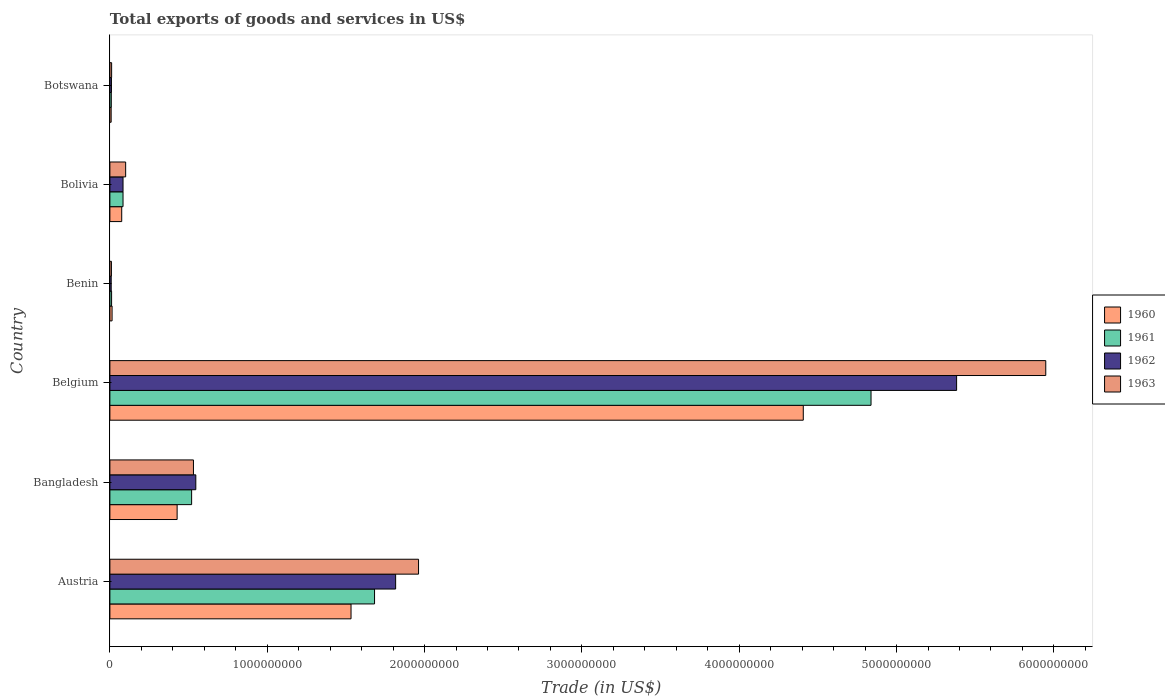Are the number of bars per tick equal to the number of legend labels?
Offer a very short reply. Yes. Are the number of bars on each tick of the Y-axis equal?
Your response must be concise. Yes. What is the label of the 1st group of bars from the top?
Make the answer very short. Botswana. In how many cases, is the number of bars for a given country not equal to the number of legend labels?
Make the answer very short. 0. What is the total exports of goods and services in 1961 in Austria?
Make the answer very short. 1.68e+09. Across all countries, what is the maximum total exports of goods and services in 1960?
Provide a short and direct response. 4.41e+09. Across all countries, what is the minimum total exports of goods and services in 1961?
Your answer should be very brief. 8.95e+06. In which country was the total exports of goods and services in 1960 maximum?
Make the answer very short. Belgium. In which country was the total exports of goods and services in 1961 minimum?
Your answer should be very brief. Botswana. What is the total total exports of goods and services in 1960 in the graph?
Ensure brevity in your answer.  6.46e+09. What is the difference between the total exports of goods and services in 1961 in Bangladesh and that in Belgium?
Offer a terse response. -4.32e+09. What is the difference between the total exports of goods and services in 1962 in Botswana and the total exports of goods and services in 1961 in Belgium?
Give a very brief answer. -4.83e+09. What is the average total exports of goods and services in 1960 per country?
Your response must be concise. 1.08e+09. What is the difference between the total exports of goods and services in 1961 and total exports of goods and services in 1960 in Bolivia?
Your answer should be very brief. 8.35e+06. What is the ratio of the total exports of goods and services in 1962 in Austria to that in Belgium?
Your answer should be very brief. 0.34. Is the difference between the total exports of goods and services in 1961 in Austria and Belgium greater than the difference between the total exports of goods and services in 1960 in Austria and Belgium?
Provide a short and direct response. No. What is the difference between the highest and the second highest total exports of goods and services in 1960?
Your answer should be very brief. 2.87e+09. What is the difference between the highest and the lowest total exports of goods and services in 1963?
Ensure brevity in your answer.  5.94e+09. Is the sum of the total exports of goods and services in 1961 in Bangladesh and Bolivia greater than the maximum total exports of goods and services in 1960 across all countries?
Your answer should be very brief. No. Is it the case that in every country, the sum of the total exports of goods and services in 1963 and total exports of goods and services in 1960 is greater than the total exports of goods and services in 1962?
Your answer should be very brief. Yes. Are all the bars in the graph horizontal?
Provide a succinct answer. Yes. How many countries are there in the graph?
Your answer should be very brief. 6. What is the difference between two consecutive major ticks on the X-axis?
Your response must be concise. 1.00e+09. Are the values on the major ticks of X-axis written in scientific E-notation?
Provide a succinct answer. No. Where does the legend appear in the graph?
Provide a short and direct response. Center right. How are the legend labels stacked?
Ensure brevity in your answer.  Vertical. What is the title of the graph?
Your answer should be very brief. Total exports of goods and services in US$. What is the label or title of the X-axis?
Offer a terse response. Trade (in US$). What is the Trade (in US$) of 1960 in Austria?
Keep it short and to the point. 1.53e+09. What is the Trade (in US$) of 1961 in Austria?
Provide a succinct answer. 1.68e+09. What is the Trade (in US$) in 1962 in Austria?
Offer a very short reply. 1.82e+09. What is the Trade (in US$) in 1963 in Austria?
Your answer should be compact. 1.96e+09. What is the Trade (in US$) in 1960 in Bangladesh?
Give a very brief answer. 4.27e+08. What is the Trade (in US$) in 1961 in Bangladesh?
Your response must be concise. 5.19e+08. What is the Trade (in US$) in 1962 in Bangladesh?
Provide a succinct answer. 5.46e+08. What is the Trade (in US$) of 1963 in Bangladesh?
Keep it short and to the point. 5.31e+08. What is the Trade (in US$) in 1960 in Belgium?
Offer a very short reply. 4.41e+09. What is the Trade (in US$) in 1961 in Belgium?
Give a very brief answer. 4.84e+09. What is the Trade (in US$) of 1962 in Belgium?
Your answer should be compact. 5.38e+09. What is the Trade (in US$) of 1963 in Belgium?
Your response must be concise. 5.95e+09. What is the Trade (in US$) in 1960 in Benin?
Ensure brevity in your answer.  1.39e+07. What is the Trade (in US$) in 1961 in Benin?
Give a very brief answer. 1.08e+07. What is the Trade (in US$) of 1962 in Benin?
Keep it short and to the point. 8.32e+06. What is the Trade (in US$) of 1963 in Benin?
Offer a very short reply. 9.70e+06. What is the Trade (in US$) of 1960 in Bolivia?
Make the answer very short. 7.51e+07. What is the Trade (in US$) of 1961 in Bolivia?
Keep it short and to the point. 8.35e+07. What is the Trade (in US$) in 1962 in Bolivia?
Provide a succinct answer. 8.35e+07. What is the Trade (in US$) in 1963 in Bolivia?
Provide a succinct answer. 1.00e+08. What is the Trade (in US$) in 1960 in Botswana?
Your answer should be compact. 7.99e+06. What is the Trade (in US$) in 1961 in Botswana?
Provide a succinct answer. 8.95e+06. What is the Trade (in US$) in 1962 in Botswana?
Offer a very short reply. 9.95e+06. What is the Trade (in US$) in 1963 in Botswana?
Your response must be concise. 1.10e+07. Across all countries, what is the maximum Trade (in US$) in 1960?
Provide a succinct answer. 4.41e+09. Across all countries, what is the maximum Trade (in US$) of 1961?
Offer a very short reply. 4.84e+09. Across all countries, what is the maximum Trade (in US$) in 1962?
Offer a very short reply. 5.38e+09. Across all countries, what is the maximum Trade (in US$) in 1963?
Your answer should be compact. 5.95e+09. Across all countries, what is the minimum Trade (in US$) in 1960?
Ensure brevity in your answer.  7.99e+06. Across all countries, what is the minimum Trade (in US$) of 1961?
Keep it short and to the point. 8.95e+06. Across all countries, what is the minimum Trade (in US$) in 1962?
Your answer should be compact. 8.32e+06. Across all countries, what is the minimum Trade (in US$) of 1963?
Offer a terse response. 9.70e+06. What is the total Trade (in US$) in 1960 in the graph?
Your answer should be compact. 6.46e+09. What is the total Trade (in US$) of 1961 in the graph?
Keep it short and to the point. 7.14e+09. What is the total Trade (in US$) in 1962 in the graph?
Give a very brief answer. 7.85e+09. What is the total Trade (in US$) in 1963 in the graph?
Your response must be concise. 8.56e+09. What is the difference between the Trade (in US$) of 1960 in Austria and that in Bangladesh?
Ensure brevity in your answer.  1.11e+09. What is the difference between the Trade (in US$) of 1961 in Austria and that in Bangladesh?
Offer a terse response. 1.16e+09. What is the difference between the Trade (in US$) of 1962 in Austria and that in Bangladesh?
Your answer should be very brief. 1.27e+09. What is the difference between the Trade (in US$) in 1963 in Austria and that in Bangladesh?
Offer a terse response. 1.43e+09. What is the difference between the Trade (in US$) in 1960 in Austria and that in Belgium?
Give a very brief answer. -2.87e+09. What is the difference between the Trade (in US$) in 1961 in Austria and that in Belgium?
Give a very brief answer. -3.16e+09. What is the difference between the Trade (in US$) in 1962 in Austria and that in Belgium?
Your response must be concise. -3.57e+09. What is the difference between the Trade (in US$) of 1963 in Austria and that in Belgium?
Your response must be concise. -3.99e+09. What is the difference between the Trade (in US$) of 1960 in Austria and that in Benin?
Keep it short and to the point. 1.52e+09. What is the difference between the Trade (in US$) of 1961 in Austria and that in Benin?
Ensure brevity in your answer.  1.67e+09. What is the difference between the Trade (in US$) of 1962 in Austria and that in Benin?
Provide a short and direct response. 1.81e+09. What is the difference between the Trade (in US$) in 1963 in Austria and that in Benin?
Provide a short and direct response. 1.95e+09. What is the difference between the Trade (in US$) of 1960 in Austria and that in Bolivia?
Your response must be concise. 1.46e+09. What is the difference between the Trade (in US$) in 1961 in Austria and that in Bolivia?
Offer a terse response. 1.60e+09. What is the difference between the Trade (in US$) of 1962 in Austria and that in Bolivia?
Your answer should be compact. 1.73e+09. What is the difference between the Trade (in US$) of 1963 in Austria and that in Bolivia?
Keep it short and to the point. 1.86e+09. What is the difference between the Trade (in US$) of 1960 in Austria and that in Botswana?
Offer a terse response. 1.52e+09. What is the difference between the Trade (in US$) in 1961 in Austria and that in Botswana?
Your answer should be compact. 1.67e+09. What is the difference between the Trade (in US$) of 1962 in Austria and that in Botswana?
Your answer should be compact. 1.81e+09. What is the difference between the Trade (in US$) of 1963 in Austria and that in Botswana?
Provide a succinct answer. 1.95e+09. What is the difference between the Trade (in US$) of 1960 in Bangladesh and that in Belgium?
Offer a terse response. -3.98e+09. What is the difference between the Trade (in US$) of 1961 in Bangladesh and that in Belgium?
Your answer should be compact. -4.32e+09. What is the difference between the Trade (in US$) of 1962 in Bangladesh and that in Belgium?
Offer a terse response. -4.84e+09. What is the difference between the Trade (in US$) of 1963 in Bangladesh and that in Belgium?
Provide a succinct answer. -5.42e+09. What is the difference between the Trade (in US$) in 1960 in Bangladesh and that in Benin?
Ensure brevity in your answer.  4.13e+08. What is the difference between the Trade (in US$) of 1961 in Bangladesh and that in Benin?
Keep it short and to the point. 5.09e+08. What is the difference between the Trade (in US$) in 1962 in Bangladesh and that in Benin?
Your response must be concise. 5.38e+08. What is the difference between the Trade (in US$) in 1963 in Bangladesh and that in Benin?
Give a very brief answer. 5.21e+08. What is the difference between the Trade (in US$) of 1960 in Bangladesh and that in Bolivia?
Ensure brevity in your answer.  3.52e+08. What is the difference between the Trade (in US$) of 1961 in Bangladesh and that in Bolivia?
Ensure brevity in your answer.  4.36e+08. What is the difference between the Trade (in US$) in 1962 in Bangladesh and that in Bolivia?
Offer a terse response. 4.63e+08. What is the difference between the Trade (in US$) of 1963 in Bangladesh and that in Bolivia?
Offer a terse response. 4.31e+08. What is the difference between the Trade (in US$) of 1960 in Bangladesh and that in Botswana?
Offer a terse response. 4.19e+08. What is the difference between the Trade (in US$) of 1961 in Bangladesh and that in Botswana?
Ensure brevity in your answer.  5.10e+08. What is the difference between the Trade (in US$) of 1962 in Bangladesh and that in Botswana?
Provide a succinct answer. 5.36e+08. What is the difference between the Trade (in US$) of 1963 in Bangladesh and that in Botswana?
Provide a short and direct response. 5.20e+08. What is the difference between the Trade (in US$) of 1960 in Belgium and that in Benin?
Make the answer very short. 4.39e+09. What is the difference between the Trade (in US$) in 1961 in Belgium and that in Benin?
Your answer should be compact. 4.83e+09. What is the difference between the Trade (in US$) in 1962 in Belgium and that in Benin?
Make the answer very short. 5.37e+09. What is the difference between the Trade (in US$) in 1963 in Belgium and that in Benin?
Make the answer very short. 5.94e+09. What is the difference between the Trade (in US$) in 1960 in Belgium and that in Bolivia?
Provide a succinct answer. 4.33e+09. What is the difference between the Trade (in US$) in 1961 in Belgium and that in Bolivia?
Ensure brevity in your answer.  4.75e+09. What is the difference between the Trade (in US$) of 1962 in Belgium and that in Bolivia?
Offer a terse response. 5.30e+09. What is the difference between the Trade (in US$) of 1963 in Belgium and that in Bolivia?
Give a very brief answer. 5.85e+09. What is the difference between the Trade (in US$) in 1960 in Belgium and that in Botswana?
Provide a succinct answer. 4.40e+09. What is the difference between the Trade (in US$) of 1961 in Belgium and that in Botswana?
Offer a terse response. 4.83e+09. What is the difference between the Trade (in US$) of 1962 in Belgium and that in Botswana?
Provide a short and direct response. 5.37e+09. What is the difference between the Trade (in US$) in 1963 in Belgium and that in Botswana?
Provide a succinct answer. 5.94e+09. What is the difference between the Trade (in US$) of 1960 in Benin and that in Bolivia?
Your answer should be compact. -6.13e+07. What is the difference between the Trade (in US$) of 1961 in Benin and that in Bolivia?
Offer a very short reply. -7.27e+07. What is the difference between the Trade (in US$) in 1962 in Benin and that in Bolivia?
Provide a short and direct response. -7.52e+07. What is the difference between the Trade (in US$) in 1963 in Benin and that in Bolivia?
Keep it short and to the point. -9.05e+07. What is the difference between the Trade (in US$) in 1960 in Benin and that in Botswana?
Your answer should be very brief. 5.86e+06. What is the difference between the Trade (in US$) in 1961 in Benin and that in Botswana?
Your answer should be compact. 1.85e+06. What is the difference between the Trade (in US$) in 1962 in Benin and that in Botswana?
Keep it short and to the point. -1.64e+06. What is the difference between the Trade (in US$) of 1963 in Benin and that in Botswana?
Your answer should be very brief. -1.34e+06. What is the difference between the Trade (in US$) in 1960 in Bolivia and that in Botswana?
Offer a terse response. 6.71e+07. What is the difference between the Trade (in US$) of 1961 in Bolivia and that in Botswana?
Offer a very short reply. 7.45e+07. What is the difference between the Trade (in US$) of 1962 in Bolivia and that in Botswana?
Provide a succinct answer. 7.35e+07. What is the difference between the Trade (in US$) of 1963 in Bolivia and that in Botswana?
Offer a terse response. 8.91e+07. What is the difference between the Trade (in US$) in 1960 in Austria and the Trade (in US$) in 1961 in Bangladesh?
Ensure brevity in your answer.  1.01e+09. What is the difference between the Trade (in US$) of 1960 in Austria and the Trade (in US$) of 1962 in Bangladesh?
Your answer should be very brief. 9.87e+08. What is the difference between the Trade (in US$) of 1960 in Austria and the Trade (in US$) of 1963 in Bangladesh?
Your response must be concise. 1.00e+09. What is the difference between the Trade (in US$) in 1961 in Austria and the Trade (in US$) in 1962 in Bangladesh?
Provide a short and direct response. 1.14e+09. What is the difference between the Trade (in US$) in 1961 in Austria and the Trade (in US$) in 1963 in Bangladesh?
Give a very brief answer. 1.15e+09. What is the difference between the Trade (in US$) of 1962 in Austria and the Trade (in US$) of 1963 in Bangladesh?
Give a very brief answer. 1.29e+09. What is the difference between the Trade (in US$) of 1960 in Austria and the Trade (in US$) of 1961 in Belgium?
Offer a very short reply. -3.31e+09. What is the difference between the Trade (in US$) in 1960 in Austria and the Trade (in US$) in 1962 in Belgium?
Your answer should be very brief. -3.85e+09. What is the difference between the Trade (in US$) of 1960 in Austria and the Trade (in US$) of 1963 in Belgium?
Your answer should be compact. -4.42e+09. What is the difference between the Trade (in US$) of 1961 in Austria and the Trade (in US$) of 1962 in Belgium?
Your answer should be very brief. -3.70e+09. What is the difference between the Trade (in US$) of 1961 in Austria and the Trade (in US$) of 1963 in Belgium?
Make the answer very short. -4.27e+09. What is the difference between the Trade (in US$) of 1962 in Austria and the Trade (in US$) of 1963 in Belgium?
Give a very brief answer. -4.13e+09. What is the difference between the Trade (in US$) in 1960 in Austria and the Trade (in US$) in 1961 in Benin?
Keep it short and to the point. 1.52e+09. What is the difference between the Trade (in US$) in 1960 in Austria and the Trade (in US$) in 1962 in Benin?
Offer a very short reply. 1.52e+09. What is the difference between the Trade (in US$) in 1960 in Austria and the Trade (in US$) in 1963 in Benin?
Offer a terse response. 1.52e+09. What is the difference between the Trade (in US$) of 1961 in Austria and the Trade (in US$) of 1962 in Benin?
Your answer should be compact. 1.67e+09. What is the difference between the Trade (in US$) in 1961 in Austria and the Trade (in US$) in 1963 in Benin?
Provide a succinct answer. 1.67e+09. What is the difference between the Trade (in US$) in 1962 in Austria and the Trade (in US$) in 1963 in Benin?
Provide a short and direct response. 1.81e+09. What is the difference between the Trade (in US$) in 1960 in Austria and the Trade (in US$) in 1961 in Bolivia?
Provide a short and direct response. 1.45e+09. What is the difference between the Trade (in US$) of 1960 in Austria and the Trade (in US$) of 1962 in Bolivia?
Make the answer very short. 1.45e+09. What is the difference between the Trade (in US$) in 1960 in Austria and the Trade (in US$) in 1963 in Bolivia?
Your response must be concise. 1.43e+09. What is the difference between the Trade (in US$) in 1961 in Austria and the Trade (in US$) in 1962 in Bolivia?
Keep it short and to the point. 1.60e+09. What is the difference between the Trade (in US$) in 1961 in Austria and the Trade (in US$) in 1963 in Bolivia?
Your response must be concise. 1.58e+09. What is the difference between the Trade (in US$) of 1962 in Austria and the Trade (in US$) of 1963 in Bolivia?
Provide a succinct answer. 1.72e+09. What is the difference between the Trade (in US$) in 1960 in Austria and the Trade (in US$) in 1961 in Botswana?
Keep it short and to the point. 1.52e+09. What is the difference between the Trade (in US$) of 1960 in Austria and the Trade (in US$) of 1962 in Botswana?
Your answer should be compact. 1.52e+09. What is the difference between the Trade (in US$) in 1960 in Austria and the Trade (in US$) in 1963 in Botswana?
Make the answer very short. 1.52e+09. What is the difference between the Trade (in US$) of 1961 in Austria and the Trade (in US$) of 1962 in Botswana?
Make the answer very short. 1.67e+09. What is the difference between the Trade (in US$) of 1961 in Austria and the Trade (in US$) of 1963 in Botswana?
Offer a very short reply. 1.67e+09. What is the difference between the Trade (in US$) of 1962 in Austria and the Trade (in US$) of 1963 in Botswana?
Offer a very short reply. 1.81e+09. What is the difference between the Trade (in US$) in 1960 in Bangladesh and the Trade (in US$) in 1961 in Belgium?
Give a very brief answer. -4.41e+09. What is the difference between the Trade (in US$) of 1960 in Bangladesh and the Trade (in US$) of 1962 in Belgium?
Offer a very short reply. -4.95e+09. What is the difference between the Trade (in US$) in 1960 in Bangladesh and the Trade (in US$) in 1963 in Belgium?
Your answer should be very brief. -5.52e+09. What is the difference between the Trade (in US$) in 1961 in Bangladesh and the Trade (in US$) in 1962 in Belgium?
Offer a terse response. -4.86e+09. What is the difference between the Trade (in US$) in 1961 in Bangladesh and the Trade (in US$) in 1963 in Belgium?
Offer a terse response. -5.43e+09. What is the difference between the Trade (in US$) in 1962 in Bangladesh and the Trade (in US$) in 1963 in Belgium?
Make the answer very short. -5.40e+09. What is the difference between the Trade (in US$) of 1960 in Bangladesh and the Trade (in US$) of 1961 in Benin?
Your response must be concise. 4.17e+08. What is the difference between the Trade (in US$) of 1960 in Bangladesh and the Trade (in US$) of 1962 in Benin?
Your response must be concise. 4.19e+08. What is the difference between the Trade (in US$) in 1960 in Bangladesh and the Trade (in US$) in 1963 in Benin?
Offer a very short reply. 4.18e+08. What is the difference between the Trade (in US$) in 1961 in Bangladesh and the Trade (in US$) in 1962 in Benin?
Make the answer very short. 5.11e+08. What is the difference between the Trade (in US$) in 1961 in Bangladesh and the Trade (in US$) in 1963 in Benin?
Your answer should be compact. 5.10e+08. What is the difference between the Trade (in US$) of 1962 in Bangladesh and the Trade (in US$) of 1963 in Benin?
Offer a very short reply. 5.36e+08. What is the difference between the Trade (in US$) of 1960 in Bangladesh and the Trade (in US$) of 1961 in Bolivia?
Your answer should be very brief. 3.44e+08. What is the difference between the Trade (in US$) of 1960 in Bangladesh and the Trade (in US$) of 1962 in Bolivia?
Your answer should be compact. 3.44e+08. What is the difference between the Trade (in US$) of 1960 in Bangladesh and the Trade (in US$) of 1963 in Bolivia?
Offer a very short reply. 3.27e+08. What is the difference between the Trade (in US$) in 1961 in Bangladesh and the Trade (in US$) in 1962 in Bolivia?
Make the answer very short. 4.36e+08. What is the difference between the Trade (in US$) of 1961 in Bangladesh and the Trade (in US$) of 1963 in Bolivia?
Keep it short and to the point. 4.19e+08. What is the difference between the Trade (in US$) of 1962 in Bangladesh and the Trade (in US$) of 1963 in Bolivia?
Ensure brevity in your answer.  4.46e+08. What is the difference between the Trade (in US$) of 1960 in Bangladesh and the Trade (in US$) of 1961 in Botswana?
Your answer should be compact. 4.18e+08. What is the difference between the Trade (in US$) in 1960 in Bangladesh and the Trade (in US$) in 1962 in Botswana?
Keep it short and to the point. 4.17e+08. What is the difference between the Trade (in US$) of 1960 in Bangladesh and the Trade (in US$) of 1963 in Botswana?
Keep it short and to the point. 4.16e+08. What is the difference between the Trade (in US$) of 1961 in Bangladesh and the Trade (in US$) of 1962 in Botswana?
Provide a short and direct response. 5.09e+08. What is the difference between the Trade (in US$) of 1961 in Bangladesh and the Trade (in US$) of 1963 in Botswana?
Your answer should be very brief. 5.08e+08. What is the difference between the Trade (in US$) of 1962 in Bangladesh and the Trade (in US$) of 1963 in Botswana?
Provide a succinct answer. 5.35e+08. What is the difference between the Trade (in US$) in 1960 in Belgium and the Trade (in US$) in 1961 in Benin?
Give a very brief answer. 4.40e+09. What is the difference between the Trade (in US$) in 1960 in Belgium and the Trade (in US$) in 1962 in Benin?
Ensure brevity in your answer.  4.40e+09. What is the difference between the Trade (in US$) in 1960 in Belgium and the Trade (in US$) in 1963 in Benin?
Offer a terse response. 4.40e+09. What is the difference between the Trade (in US$) in 1961 in Belgium and the Trade (in US$) in 1962 in Benin?
Give a very brief answer. 4.83e+09. What is the difference between the Trade (in US$) in 1961 in Belgium and the Trade (in US$) in 1963 in Benin?
Give a very brief answer. 4.83e+09. What is the difference between the Trade (in US$) of 1962 in Belgium and the Trade (in US$) of 1963 in Benin?
Keep it short and to the point. 5.37e+09. What is the difference between the Trade (in US$) in 1960 in Belgium and the Trade (in US$) in 1961 in Bolivia?
Ensure brevity in your answer.  4.32e+09. What is the difference between the Trade (in US$) in 1960 in Belgium and the Trade (in US$) in 1962 in Bolivia?
Your response must be concise. 4.32e+09. What is the difference between the Trade (in US$) of 1960 in Belgium and the Trade (in US$) of 1963 in Bolivia?
Offer a very short reply. 4.31e+09. What is the difference between the Trade (in US$) in 1961 in Belgium and the Trade (in US$) in 1962 in Bolivia?
Give a very brief answer. 4.75e+09. What is the difference between the Trade (in US$) in 1961 in Belgium and the Trade (in US$) in 1963 in Bolivia?
Ensure brevity in your answer.  4.74e+09. What is the difference between the Trade (in US$) in 1962 in Belgium and the Trade (in US$) in 1963 in Bolivia?
Make the answer very short. 5.28e+09. What is the difference between the Trade (in US$) of 1960 in Belgium and the Trade (in US$) of 1961 in Botswana?
Ensure brevity in your answer.  4.40e+09. What is the difference between the Trade (in US$) of 1960 in Belgium and the Trade (in US$) of 1962 in Botswana?
Provide a succinct answer. 4.40e+09. What is the difference between the Trade (in US$) of 1960 in Belgium and the Trade (in US$) of 1963 in Botswana?
Keep it short and to the point. 4.40e+09. What is the difference between the Trade (in US$) in 1961 in Belgium and the Trade (in US$) in 1962 in Botswana?
Make the answer very short. 4.83e+09. What is the difference between the Trade (in US$) of 1961 in Belgium and the Trade (in US$) of 1963 in Botswana?
Provide a succinct answer. 4.83e+09. What is the difference between the Trade (in US$) of 1962 in Belgium and the Trade (in US$) of 1963 in Botswana?
Offer a very short reply. 5.37e+09. What is the difference between the Trade (in US$) in 1960 in Benin and the Trade (in US$) in 1961 in Bolivia?
Make the answer very short. -6.96e+07. What is the difference between the Trade (in US$) in 1960 in Benin and the Trade (in US$) in 1962 in Bolivia?
Offer a terse response. -6.96e+07. What is the difference between the Trade (in US$) in 1960 in Benin and the Trade (in US$) in 1963 in Bolivia?
Your answer should be compact. -8.63e+07. What is the difference between the Trade (in US$) in 1961 in Benin and the Trade (in US$) in 1962 in Bolivia?
Make the answer very short. -7.27e+07. What is the difference between the Trade (in US$) in 1961 in Benin and the Trade (in US$) in 1963 in Bolivia?
Offer a terse response. -8.94e+07. What is the difference between the Trade (in US$) in 1962 in Benin and the Trade (in US$) in 1963 in Bolivia?
Your answer should be compact. -9.19e+07. What is the difference between the Trade (in US$) in 1960 in Benin and the Trade (in US$) in 1961 in Botswana?
Keep it short and to the point. 4.90e+06. What is the difference between the Trade (in US$) of 1960 in Benin and the Trade (in US$) of 1962 in Botswana?
Your response must be concise. 3.90e+06. What is the difference between the Trade (in US$) in 1960 in Benin and the Trade (in US$) in 1963 in Botswana?
Keep it short and to the point. 2.81e+06. What is the difference between the Trade (in US$) in 1961 in Benin and the Trade (in US$) in 1962 in Botswana?
Provide a short and direct response. 8.48e+05. What is the difference between the Trade (in US$) of 1961 in Benin and the Trade (in US$) of 1963 in Botswana?
Offer a terse response. -2.43e+05. What is the difference between the Trade (in US$) in 1962 in Benin and the Trade (in US$) in 1963 in Botswana?
Your answer should be very brief. -2.73e+06. What is the difference between the Trade (in US$) in 1960 in Bolivia and the Trade (in US$) in 1961 in Botswana?
Your response must be concise. 6.62e+07. What is the difference between the Trade (in US$) in 1960 in Bolivia and the Trade (in US$) in 1962 in Botswana?
Provide a short and direct response. 6.52e+07. What is the difference between the Trade (in US$) of 1960 in Bolivia and the Trade (in US$) of 1963 in Botswana?
Your answer should be compact. 6.41e+07. What is the difference between the Trade (in US$) in 1961 in Bolivia and the Trade (in US$) in 1962 in Botswana?
Offer a very short reply. 7.35e+07. What is the difference between the Trade (in US$) in 1961 in Bolivia and the Trade (in US$) in 1963 in Botswana?
Keep it short and to the point. 7.24e+07. What is the difference between the Trade (in US$) of 1962 in Bolivia and the Trade (in US$) of 1963 in Botswana?
Give a very brief answer. 7.24e+07. What is the average Trade (in US$) of 1960 per country?
Provide a succinct answer. 1.08e+09. What is the average Trade (in US$) in 1961 per country?
Provide a short and direct response. 1.19e+09. What is the average Trade (in US$) of 1962 per country?
Provide a short and direct response. 1.31e+09. What is the average Trade (in US$) of 1963 per country?
Make the answer very short. 1.43e+09. What is the difference between the Trade (in US$) of 1960 and Trade (in US$) of 1961 in Austria?
Your answer should be very brief. -1.49e+08. What is the difference between the Trade (in US$) of 1960 and Trade (in US$) of 1962 in Austria?
Give a very brief answer. -2.84e+08. What is the difference between the Trade (in US$) of 1960 and Trade (in US$) of 1963 in Austria?
Provide a short and direct response. -4.29e+08. What is the difference between the Trade (in US$) in 1961 and Trade (in US$) in 1962 in Austria?
Provide a short and direct response. -1.34e+08. What is the difference between the Trade (in US$) of 1961 and Trade (in US$) of 1963 in Austria?
Keep it short and to the point. -2.80e+08. What is the difference between the Trade (in US$) of 1962 and Trade (in US$) of 1963 in Austria?
Provide a short and direct response. -1.46e+08. What is the difference between the Trade (in US$) in 1960 and Trade (in US$) in 1961 in Bangladesh?
Keep it short and to the point. -9.21e+07. What is the difference between the Trade (in US$) of 1960 and Trade (in US$) of 1962 in Bangladesh?
Make the answer very short. -1.19e+08. What is the difference between the Trade (in US$) of 1960 and Trade (in US$) of 1963 in Bangladesh?
Ensure brevity in your answer.  -1.04e+08. What is the difference between the Trade (in US$) of 1961 and Trade (in US$) of 1962 in Bangladesh?
Your answer should be compact. -2.66e+07. What is the difference between the Trade (in US$) of 1961 and Trade (in US$) of 1963 in Bangladesh?
Provide a short and direct response. -1.16e+07. What is the difference between the Trade (in US$) of 1962 and Trade (in US$) of 1963 in Bangladesh?
Provide a succinct answer. 1.50e+07. What is the difference between the Trade (in US$) in 1960 and Trade (in US$) in 1961 in Belgium?
Your answer should be compact. -4.31e+08. What is the difference between the Trade (in US$) in 1960 and Trade (in US$) in 1962 in Belgium?
Ensure brevity in your answer.  -9.75e+08. What is the difference between the Trade (in US$) in 1960 and Trade (in US$) in 1963 in Belgium?
Offer a very short reply. -1.54e+09. What is the difference between the Trade (in US$) of 1961 and Trade (in US$) of 1962 in Belgium?
Provide a succinct answer. -5.44e+08. What is the difference between the Trade (in US$) in 1961 and Trade (in US$) in 1963 in Belgium?
Provide a short and direct response. -1.11e+09. What is the difference between the Trade (in US$) of 1962 and Trade (in US$) of 1963 in Belgium?
Give a very brief answer. -5.67e+08. What is the difference between the Trade (in US$) in 1960 and Trade (in US$) in 1961 in Benin?
Provide a short and direct response. 3.05e+06. What is the difference between the Trade (in US$) in 1960 and Trade (in US$) in 1962 in Benin?
Your answer should be very brief. 5.53e+06. What is the difference between the Trade (in US$) in 1960 and Trade (in US$) in 1963 in Benin?
Keep it short and to the point. 4.15e+06. What is the difference between the Trade (in US$) of 1961 and Trade (in US$) of 1962 in Benin?
Give a very brief answer. 2.48e+06. What is the difference between the Trade (in US$) of 1961 and Trade (in US$) of 1963 in Benin?
Keep it short and to the point. 1.10e+06. What is the difference between the Trade (in US$) of 1962 and Trade (in US$) of 1963 in Benin?
Provide a succinct answer. -1.39e+06. What is the difference between the Trade (in US$) of 1960 and Trade (in US$) of 1961 in Bolivia?
Your answer should be compact. -8.35e+06. What is the difference between the Trade (in US$) in 1960 and Trade (in US$) in 1962 in Bolivia?
Offer a terse response. -8.35e+06. What is the difference between the Trade (in US$) of 1960 and Trade (in US$) of 1963 in Bolivia?
Provide a short and direct response. -2.50e+07. What is the difference between the Trade (in US$) in 1961 and Trade (in US$) in 1962 in Bolivia?
Make the answer very short. 0. What is the difference between the Trade (in US$) of 1961 and Trade (in US$) of 1963 in Bolivia?
Ensure brevity in your answer.  -1.67e+07. What is the difference between the Trade (in US$) in 1962 and Trade (in US$) in 1963 in Bolivia?
Provide a succinct answer. -1.67e+07. What is the difference between the Trade (in US$) in 1960 and Trade (in US$) in 1961 in Botswana?
Provide a short and direct response. -9.64e+05. What is the difference between the Trade (in US$) in 1960 and Trade (in US$) in 1962 in Botswana?
Your answer should be very brief. -1.96e+06. What is the difference between the Trade (in US$) in 1960 and Trade (in US$) in 1963 in Botswana?
Make the answer very short. -3.05e+06. What is the difference between the Trade (in US$) of 1961 and Trade (in US$) of 1962 in Botswana?
Offer a terse response. -9.99e+05. What is the difference between the Trade (in US$) of 1961 and Trade (in US$) of 1963 in Botswana?
Keep it short and to the point. -2.09e+06. What is the difference between the Trade (in US$) of 1962 and Trade (in US$) of 1963 in Botswana?
Ensure brevity in your answer.  -1.09e+06. What is the ratio of the Trade (in US$) of 1960 in Austria to that in Bangladesh?
Ensure brevity in your answer.  3.59. What is the ratio of the Trade (in US$) in 1961 in Austria to that in Bangladesh?
Offer a very short reply. 3.24. What is the ratio of the Trade (in US$) in 1962 in Austria to that in Bangladesh?
Make the answer very short. 3.33. What is the ratio of the Trade (in US$) of 1963 in Austria to that in Bangladesh?
Keep it short and to the point. 3.69. What is the ratio of the Trade (in US$) in 1960 in Austria to that in Belgium?
Give a very brief answer. 0.35. What is the ratio of the Trade (in US$) of 1961 in Austria to that in Belgium?
Your response must be concise. 0.35. What is the ratio of the Trade (in US$) of 1962 in Austria to that in Belgium?
Keep it short and to the point. 0.34. What is the ratio of the Trade (in US$) in 1963 in Austria to that in Belgium?
Your response must be concise. 0.33. What is the ratio of the Trade (in US$) of 1960 in Austria to that in Benin?
Provide a succinct answer. 110.65. What is the ratio of the Trade (in US$) in 1961 in Austria to that in Benin?
Give a very brief answer. 155.72. What is the ratio of the Trade (in US$) of 1962 in Austria to that in Benin?
Provide a succinct answer. 218.36. What is the ratio of the Trade (in US$) of 1963 in Austria to that in Benin?
Make the answer very short. 202.17. What is the ratio of the Trade (in US$) of 1960 in Austria to that in Bolivia?
Your response must be concise. 20.4. What is the ratio of the Trade (in US$) of 1961 in Austria to that in Bolivia?
Ensure brevity in your answer.  20.15. What is the ratio of the Trade (in US$) of 1962 in Austria to that in Bolivia?
Your answer should be very brief. 21.76. What is the ratio of the Trade (in US$) of 1963 in Austria to that in Bolivia?
Keep it short and to the point. 19.59. What is the ratio of the Trade (in US$) of 1960 in Austria to that in Botswana?
Keep it short and to the point. 191.8. What is the ratio of the Trade (in US$) of 1961 in Austria to that in Botswana?
Keep it short and to the point. 187.84. What is the ratio of the Trade (in US$) of 1962 in Austria to that in Botswana?
Your answer should be very brief. 182.46. What is the ratio of the Trade (in US$) of 1963 in Austria to that in Botswana?
Your answer should be very brief. 177.63. What is the ratio of the Trade (in US$) in 1960 in Bangladesh to that in Belgium?
Make the answer very short. 0.1. What is the ratio of the Trade (in US$) in 1961 in Bangladesh to that in Belgium?
Give a very brief answer. 0.11. What is the ratio of the Trade (in US$) of 1962 in Bangladesh to that in Belgium?
Offer a terse response. 0.1. What is the ratio of the Trade (in US$) in 1963 in Bangladesh to that in Belgium?
Your answer should be very brief. 0.09. What is the ratio of the Trade (in US$) of 1960 in Bangladesh to that in Benin?
Your response must be concise. 30.85. What is the ratio of the Trade (in US$) in 1961 in Bangladesh to that in Benin?
Give a very brief answer. 48.09. What is the ratio of the Trade (in US$) in 1962 in Bangladesh to that in Benin?
Offer a very short reply. 65.66. What is the ratio of the Trade (in US$) of 1963 in Bangladesh to that in Benin?
Offer a terse response. 54.73. What is the ratio of the Trade (in US$) in 1960 in Bangladesh to that in Bolivia?
Provide a short and direct response. 5.69. What is the ratio of the Trade (in US$) in 1961 in Bangladesh to that in Bolivia?
Give a very brief answer. 6.22. What is the ratio of the Trade (in US$) of 1962 in Bangladesh to that in Bolivia?
Your answer should be very brief. 6.54. What is the ratio of the Trade (in US$) of 1963 in Bangladesh to that in Bolivia?
Offer a terse response. 5.3. What is the ratio of the Trade (in US$) of 1960 in Bangladesh to that in Botswana?
Offer a very short reply. 53.48. What is the ratio of the Trade (in US$) of 1961 in Bangladesh to that in Botswana?
Provide a succinct answer. 58.01. What is the ratio of the Trade (in US$) of 1962 in Bangladesh to that in Botswana?
Offer a very short reply. 54.86. What is the ratio of the Trade (in US$) of 1963 in Bangladesh to that in Botswana?
Make the answer very short. 48.08. What is the ratio of the Trade (in US$) of 1960 in Belgium to that in Benin?
Your answer should be very brief. 318.15. What is the ratio of the Trade (in US$) of 1961 in Belgium to that in Benin?
Ensure brevity in your answer.  447.86. What is the ratio of the Trade (in US$) of 1962 in Belgium to that in Benin?
Your answer should be compact. 647.03. What is the ratio of the Trade (in US$) in 1963 in Belgium to that in Benin?
Ensure brevity in your answer.  613. What is the ratio of the Trade (in US$) of 1960 in Belgium to that in Bolivia?
Offer a terse response. 58.66. What is the ratio of the Trade (in US$) in 1961 in Belgium to that in Bolivia?
Keep it short and to the point. 57.95. What is the ratio of the Trade (in US$) of 1962 in Belgium to that in Bolivia?
Offer a terse response. 64.47. What is the ratio of the Trade (in US$) of 1963 in Belgium to that in Bolivia?
Provide a succinct answer. 59.38. What is the ratio of the Trade (in US$) of 1960 in Belgium to that in Botswana?
Ensure brevity in your answer.  551.52. What is the ratio of the Trade (in US$) in 1961 in Belgium to that in Botswana?
Your answer should be compact. 540.23. What is the ratio of the Trade (in US$) of 1962 in Belgium to that in Botswana?
Ensure brevity in your answer.  540.64. What is the ratio of the Trade (in US$) in 1963 in Belgium to that in Botswana?
Provide a succinct answer. 538.57. What is the ratio of the Trade (in US$) of 1960 in Benin to that in Bolivia?
Give a very brief answer. 0.18. What is the ratio of the Trade (in US$) in 1961 in Benin to that in Bolivia?
Your response must be concise. 0.13. What is the ratio of the Trade (in US$) of 1962 in Benin to that in Bolivia?
Give a very brief answer. 0.1. What is the ratio of the Trade (in US$) in 1963 in Benin to that in Bolivia?
Give a very brief answer. 0.1. What is the ratio of the Trade (in US$) in 1960 in Benin to that in Botswana?
Your response must be concise. 1.73. What is the ratio of the Trade (in US$) of 1961 in Benin to that in Botswana?
Your response must be concise. 1.21. What is the ratio of the Trade (in US$) in 1962 in Benin to that in Botswana?
Keep it short and to the point. 0.84. What is the ratio of the Trade (in US$) in 1963 in Benin to that in Botswana?
Provide a short and direct response. 0.88. What is the ratio of the Trade (in US$) in 1960 in Bolivia to that in Botswana?
Offer a terse response. 9.4. What is the ratio of the Trade (in US$) of 1961 in Bolivia to that in Botswana?
Offer a terse response. 9.32. What is the ratio of the Trade (in US$) of 1962 in Bolivia to that in Botswana?
Keep it short and to the point. 8.39. What is the ratio of the Trade (in US$) of 1963 in Bolivia to that in Botswana?
Offer a terse response. 9.07. What is the difference between the highest and the second highest Trade (in US$) of 1960?
Provide a succinct answer. 2.87e+09. What is the difference between the highest and the second highest Trade (in US$) in 1961?
Provide a succinct answer. 3.16e+09. What is the difference between the highest and the second highest Trade (in US$) of 1962?
Make the answer very short. 3.57e+09. What is the difference between the highest and the second highest Trade (in US$) of 1963?
Provide a succinct answer. 3.99e+09. What is the difference between the highest and the lowest Trade (in US$) in 1960?
Offer a very short reply. 4.40e+09. What is the difference between the highest and the lowest Trade (in US$) in 1961?
Your answer should be very brief. 4.83e+09. What is the difference between the highest and the lowest Trade (in US$) of 1962?
Make the answer very short. 5.37e+09. What is the difference between the highest and the lowest Trade (in US$) in 1963?
Provide a succinct answer. 5.94e+09. 